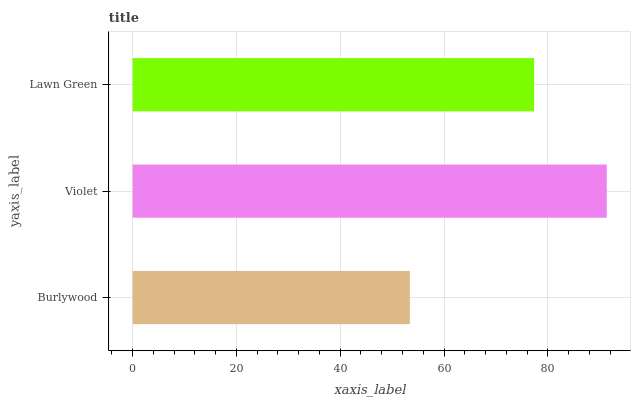Is Burlywood the minimum?
Answer yes or no. Yes. Is Violet the maximum?
Answer yes or no. Yes. Is Lawn Green the minimum?
Answer yes or no. No. Is Lawn Green the maximum?
Answer yes or no. No. Is Violet greater than Lawn Green?
Answer yes or no. Yes. Is Lawn Green less than Violet?
Answer yes or no. Yes. Is Lawn Green greater than Violet?
Answer yes or no. No. Is Violet less than Lawn Green?
Answer yes or no. No. Is Lawn Green the high median?
Answer yes or no. Yes. Is Lawn Green the low median?
Answer yes or no. Yes. Is Violet the high median?
Answer yes or no. No. Is Burlywood the low median?
Answer yes or no. No. 